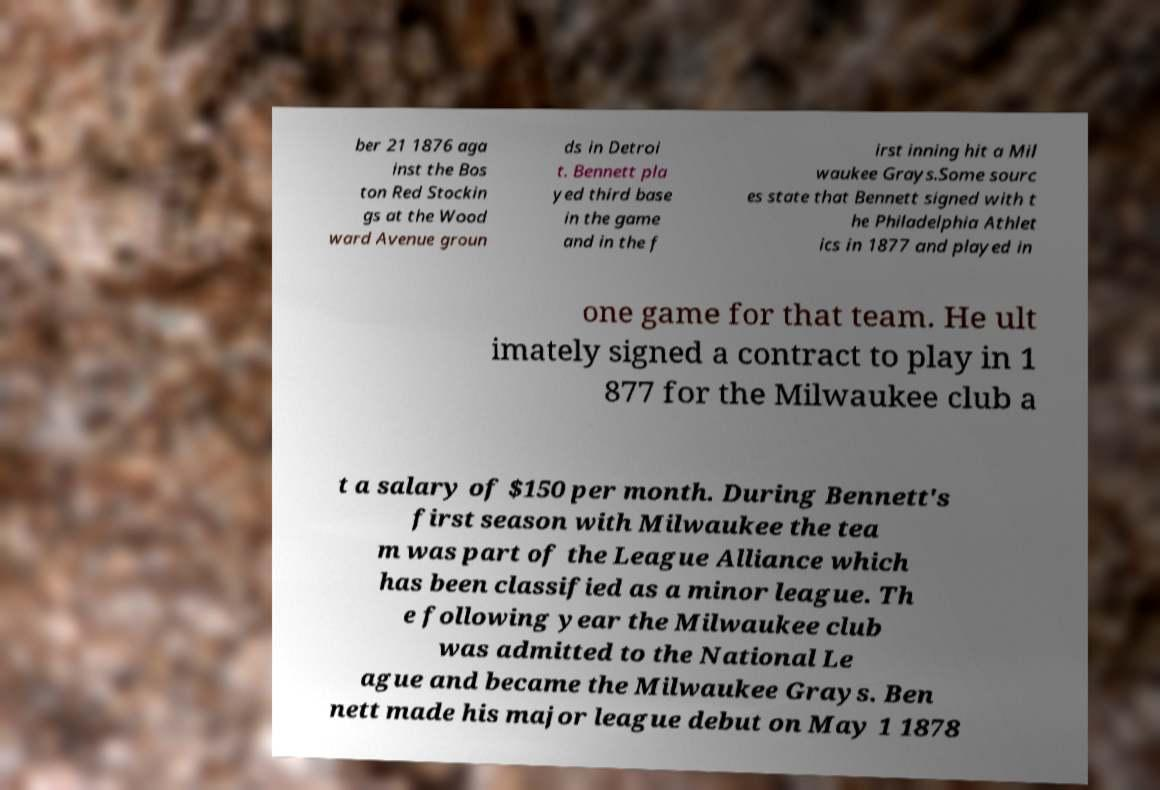Please read and relay the text visible in this image. What does it say? ber 21 1876 aga inst the Bos ton Red Stockin gs at the Wood ward Avenue groun ds in Detroi t. Bennett pla yed third base in the game and in the f irst inning hit a Mil waukee Grays.Some sourc es state that Bennett signed with t he Philadelphia Athlet ics in 1877 and played in one game for that team. He ult imately signed a contract to play in 1 877 for the Milwaukee club a t a salary of $150 per month. During Bennett's first season with Milwaukee the tea m was part of the League Alliance which has been classified as a minor league. Th e following year the Milwaukee club was admitted to the National Le ague and became the Milwaukee Grays. Ben nett made his major league debut on May 1 1878 